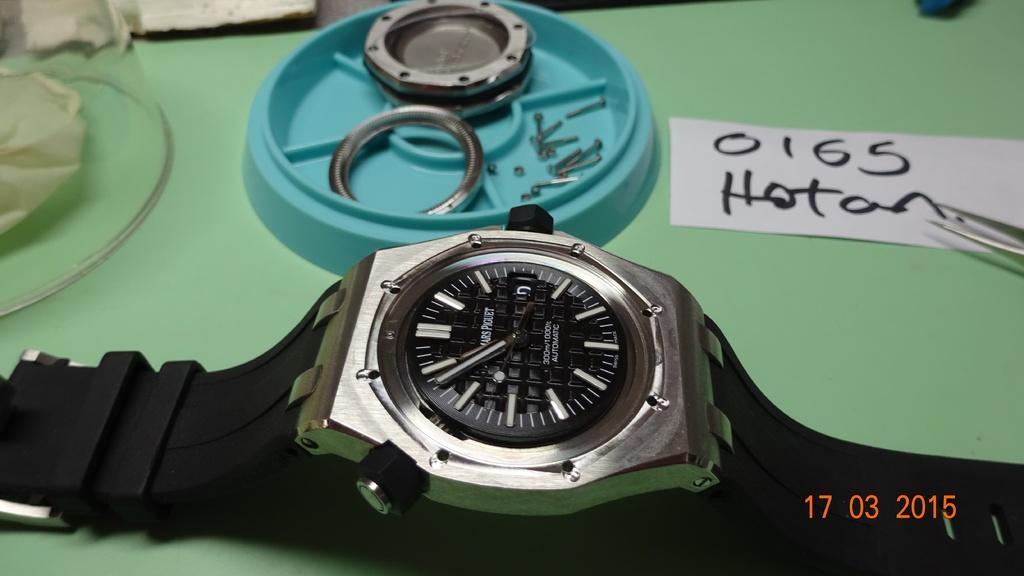What is the date printed in the lower right corner?
Your answer should be compact. 17 03 2015. 